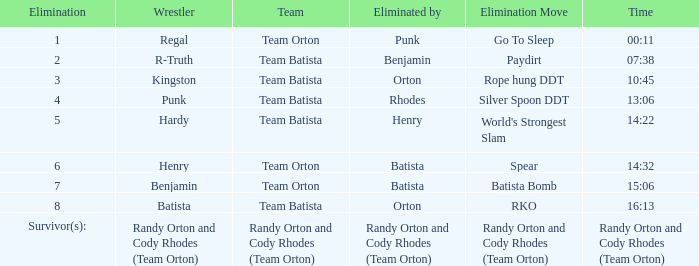Which Elimination Move is listed at Elimination 8 for Team Batista? RKO. 